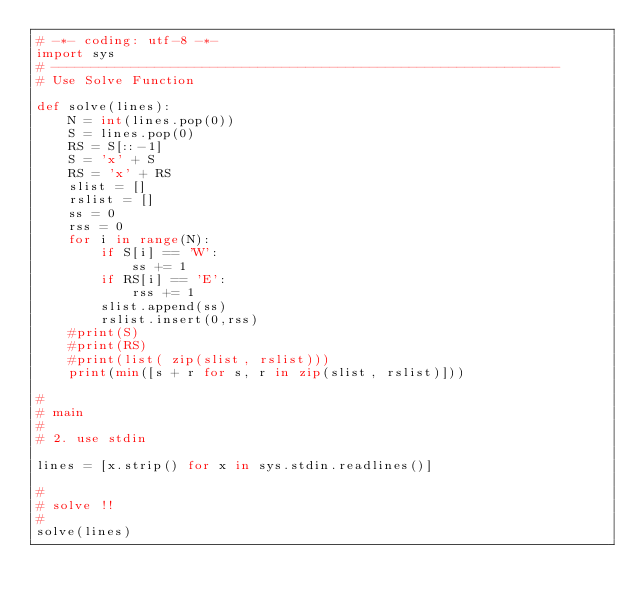<code> <loc_0><loc_0><loc_500><loc_500><_Python_># -*- coding: utf-8 -*-
import sys
# ----------------------------------------------------------------
# Use Solve Function

def solve(lines):
    N = int(lines.pop(0))
    S = lines.pop(0)
    RS = S[::-1]
    S = 'x' + S
    RS = 'x' + RS
    slist = []
    rslist = []
    ss = 0
    rss = 0
    for i in range(N):
        if S[i] == 'W':
            ss += 1
        if RS[i] == 'E':
            rss += 1
        slist.append(ss)
        rslist.insert(0,rss)
    #print(S)
    #print(RS)
    #print(list( zip(slist, rslist)))
    print(min([s + r for s, r in zip(slist, rslist)]))

#
# main
#
# 2. use stdin

lines = [x.strip() for x in sys.stdin.readlines()]

#
# solve !!
#
solve(lines)</code> 